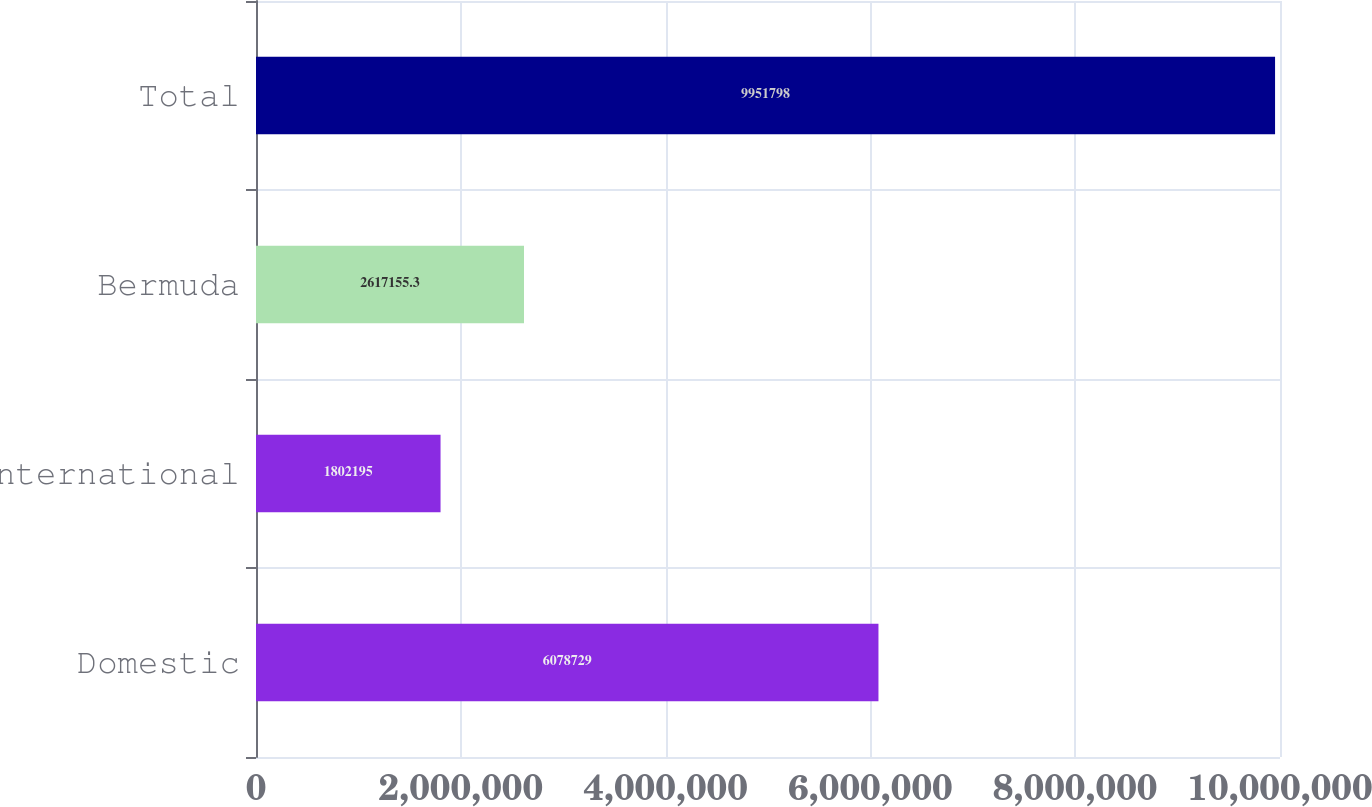Convert chart. <chart><loc_0><loc_0><loc_500><loc_500><bar_chart><fcel>Domestic<fcel>International<fcel>Bermuda<fcel>Total<nl><fcel>6.07873e+06<fcel>1.8022e+06<fcel>2.61716e+06<fcel>9.9518e+06<nl></chart> 